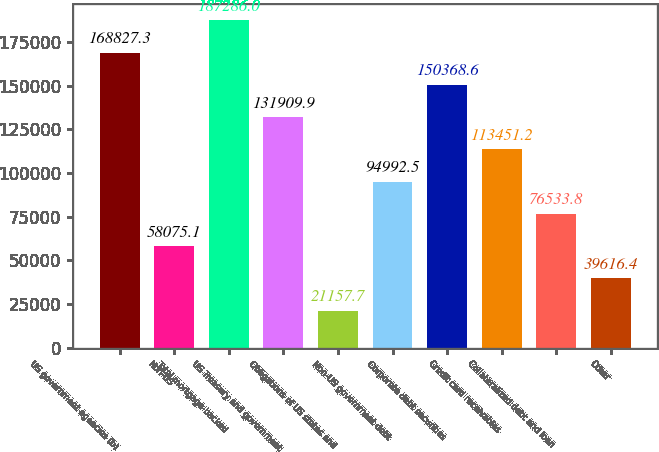<chart> <loc_0><loc_0><loc_500><loc_500><bar_chart><fcel>US government agencies (b)<fcel>Non-US<fcel>Total mortgage-backed<fcel>US Treasury and government<fcel>Obligations of US states and<fcel>Non-US government debt<fcel>Corporate debt securities<fcel>Credit card receivables<fcel>Collateralized debt and loan<fcel>Other<nl><fcel>168827<fcel>58075.1<fcel>187286<fcel>131910<fcel>21157.7<fcel>94992.5<fcel>150369<fcel>113451<fcel>76533.8<fcel>39616.4<nl></chart> 